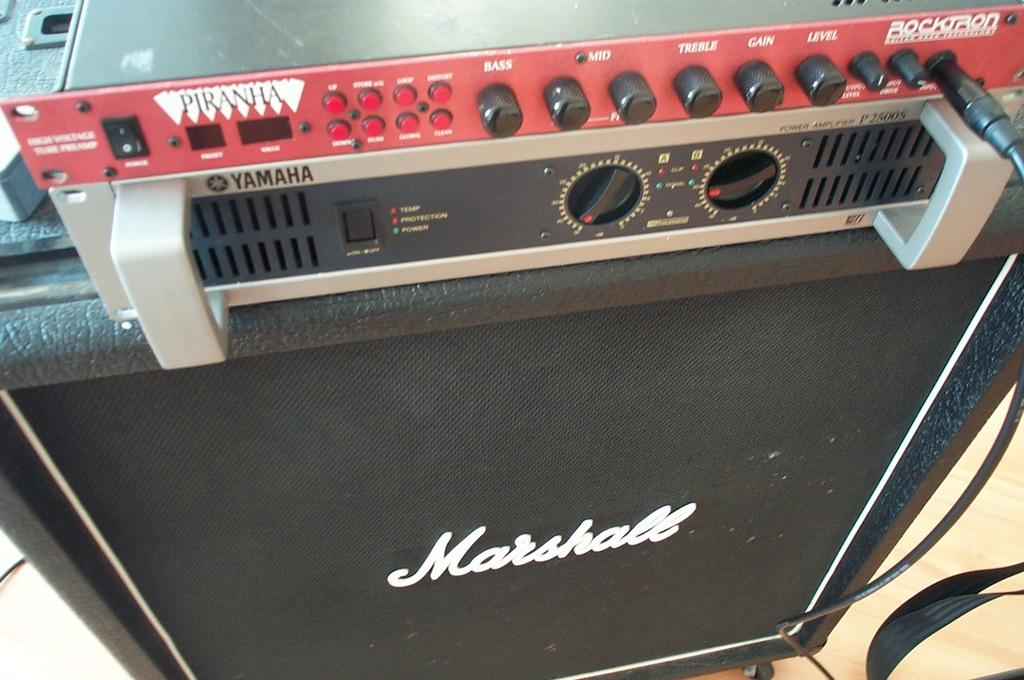<image>
Render a clear and concise summary of the photo. A speaker made by Yamaha with the word Marshall on front 